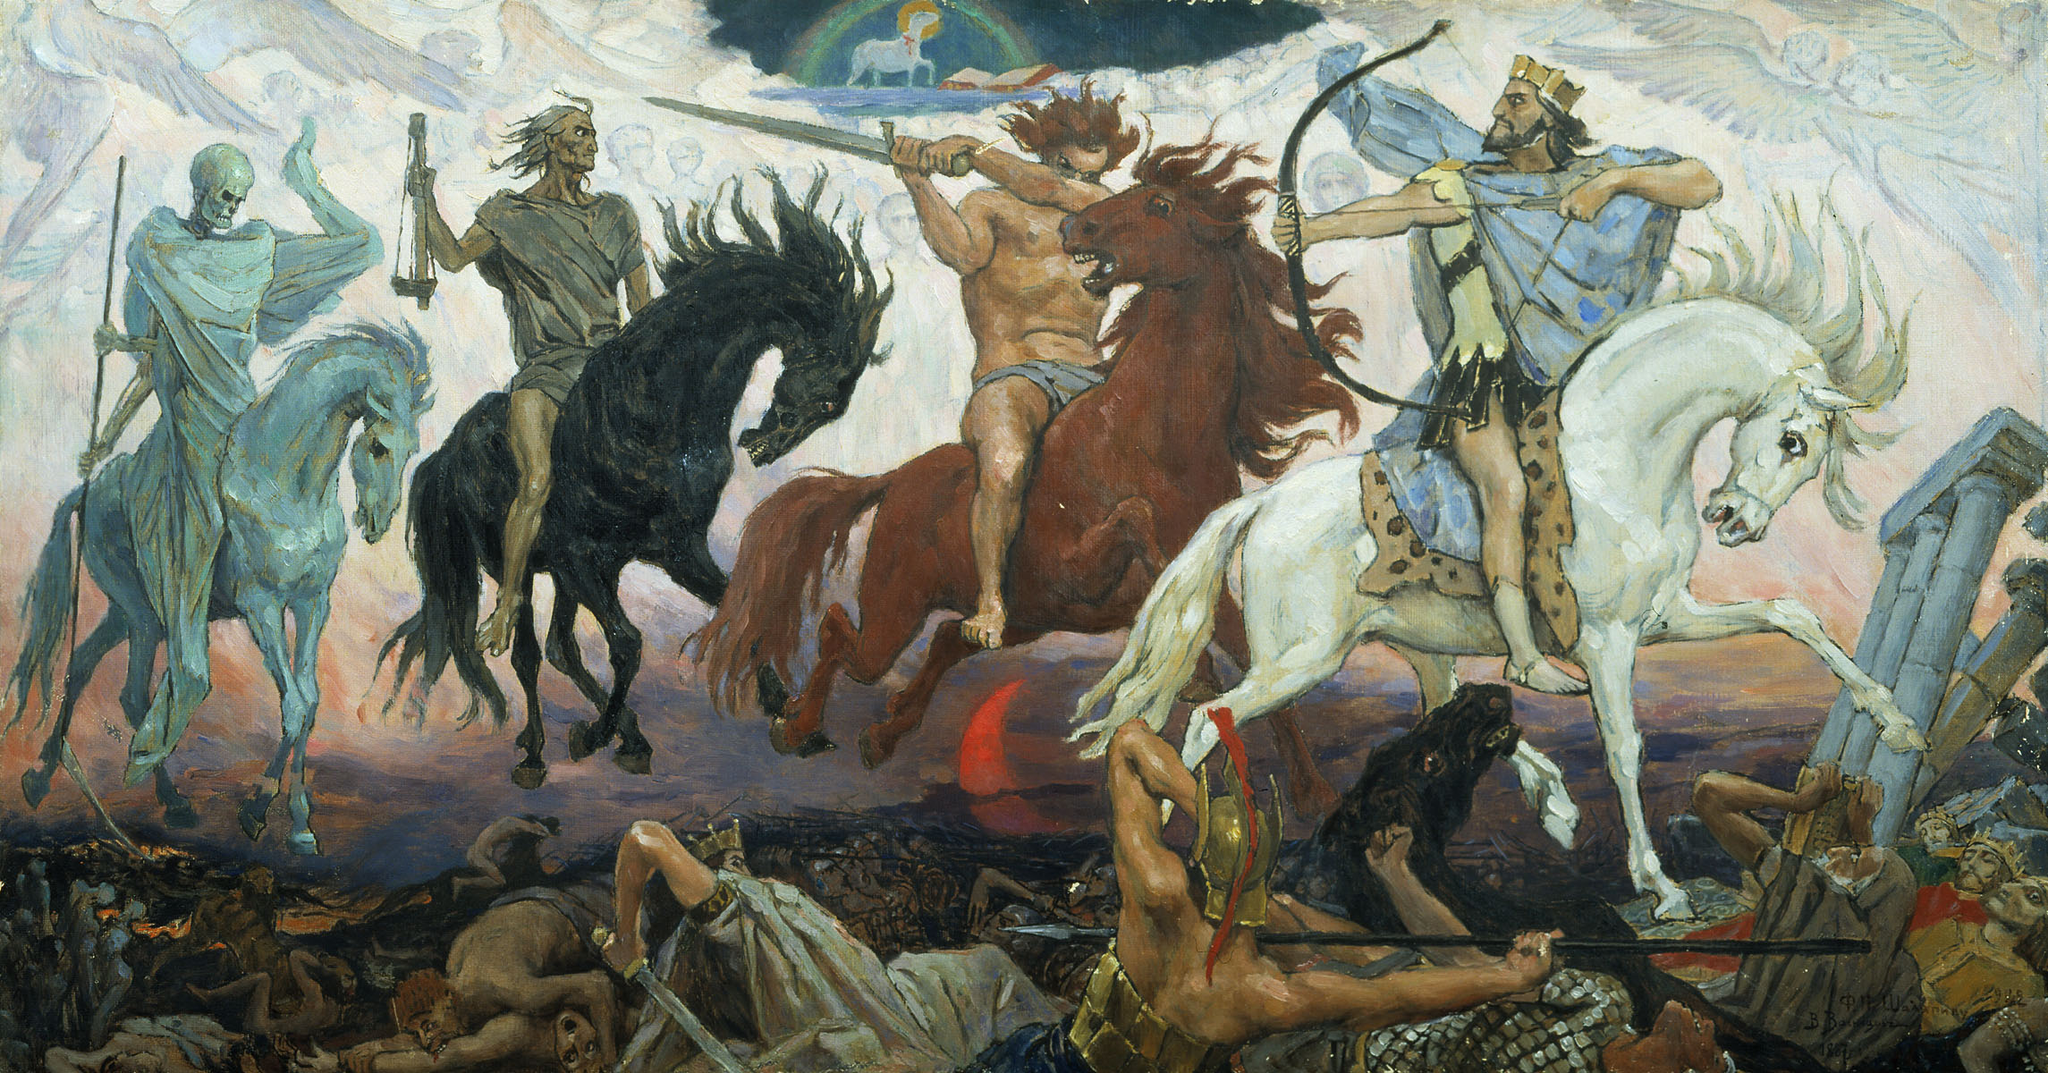What might the different colors used in this battle scene symbolize? The use of earth tones generally grounds the scene in a somber, realistic setting, suggesting the harsh realities of battle. Contrasting with this are the striking reds and blues which may symbolize the bloodshed, valor, and loyalty among the warriors. The distinct use of white and black could represent the classic dichotomy between life and death, purity and corruption, highlighting the existential stakes of the battle depicted. 